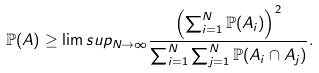<formula> <loc_0><loc_0><loc_500><loc_500>\mathbb { P } ( A ) \geq \lim s u p _ { N \rightarrow \infty } \frac { \left ( \sum _ { i = 1 } ^ { N } \mathbb { P } ( A _ { i } ) \right ) ^ { 2 } } { \sum _ { i = 1 } ^ { N } \sum _ { j = 1 } ^ { N } \mathbb { P } ( A _ { i } \cap A _ { j } ) } .</formula> 